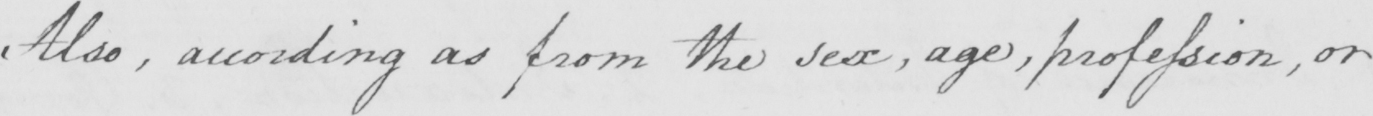Please transcribe the handwritten text in this image. Also , according as from the sex , age , profession , or 